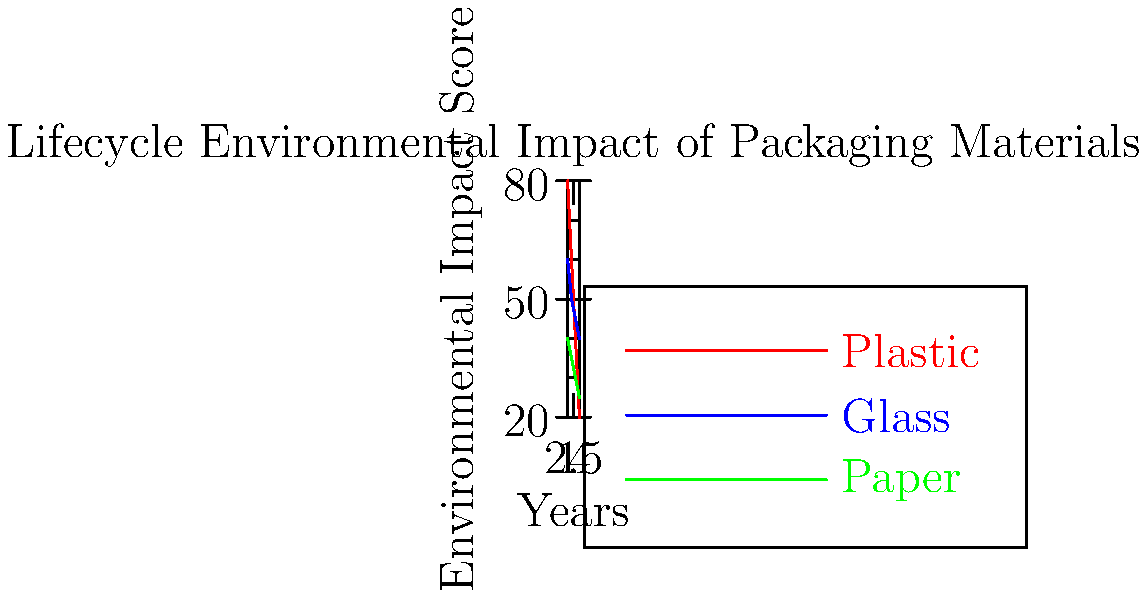Based on the infographic comparing the lifecycle environmental impact of different packaging materials over time, which material shows the most significant reduction in environmental impact from Year 1 to Year 4, and what percentage reduction does it achieve? To determine which material shows the most significant reduction in environmental impact and calculate the percentage reduction:

1. Identify the starting (Year 1) and ending (Year 4) values for each material:
   Plastic: Start = 80, End = 20
   Glass: Start = 60, End = 40
   Paper: Start = 40, End = 25

2. Calculate the absolute reduction for each material:
   Plastic: 80 - 20 = 60
   Glass: 60 - 40 = 20
   Paper: 40 - 25 = 15

3. Plastic shows the largest absolute reduction.

4. Calculate the percentage reduction for plastic:
   Percentage reduction = (Reduction / Starting value) × 100
   = (60 / 80) × 100 = 75%

Therefore, plastic shows the most significant reduction in environmental impact, with a 75% reduction from Year 1 to Year 4.
Answer: Plastic, 75% reduction 